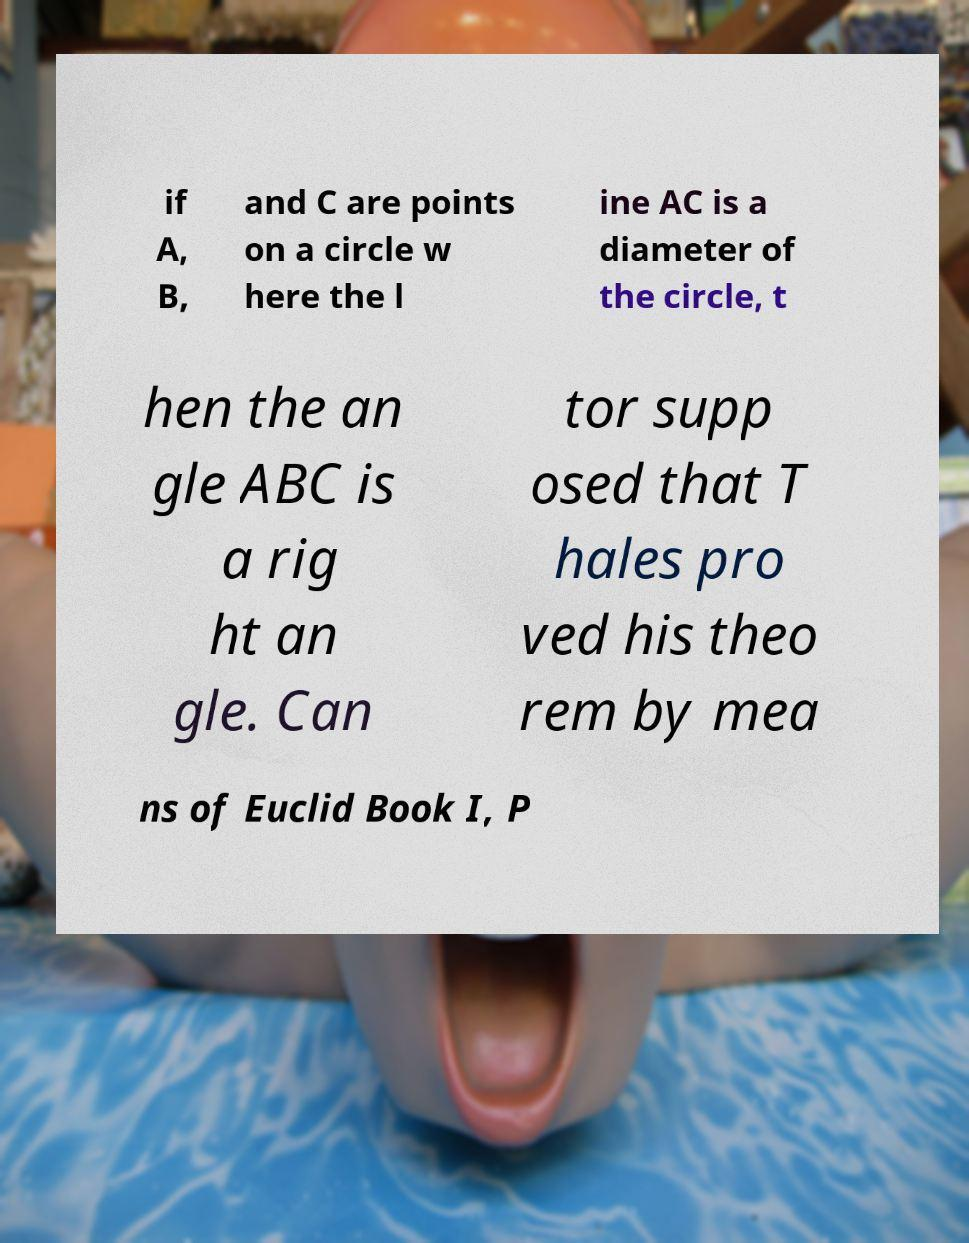For documentation purposes, I need the text within this image transcribed. Could you provide that? if A, B, and C are points on a circle w here the l ine AC is a diameter of the circle, t hen the an gle ABC is a rig ht an gle. Can tor supp osed that T hales pro ved his theo rem by mea ns of Euclid Book I, P 